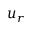<formula> <loc_0><loc_0><loc_500><loc_500>u _ { r }</formula> 